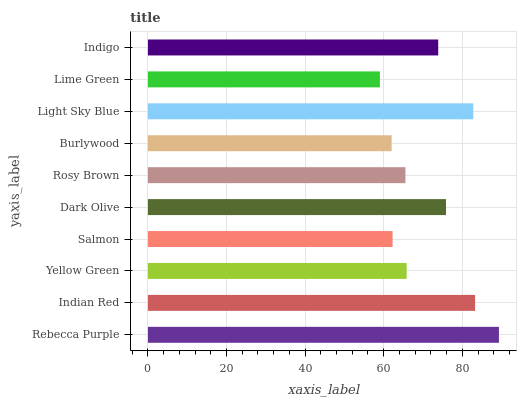Is Lime Green the minimum?
Answer yes or no. Yes. Is Rebecca Purple the maximum?
Answer yes or no. Yes. Is Indian Red the minimum?
Answer yes or no. No. Is Indian Red the maximum?
Answer yes or no. No. Is Rebecca Purple greater than Indian Red?
Answer yes or no. Yes. Is Indian Red less than Rebecca Purple?
Answer yes or no. Yes. Is Indian Red greater than Rebecca Purple?
Answer yes or no. No. Is Rebecca Purple less than Indian Red?
Answer yes or no. No. Is Indigo the high median?
Answer yes or no. Yes. Is Yellow Green the low median?
Answer yes or no. Yes. Is Salmon the high median?
Answer yes or no. No. Is Indigo the low median?
Answer yes or no. No. 